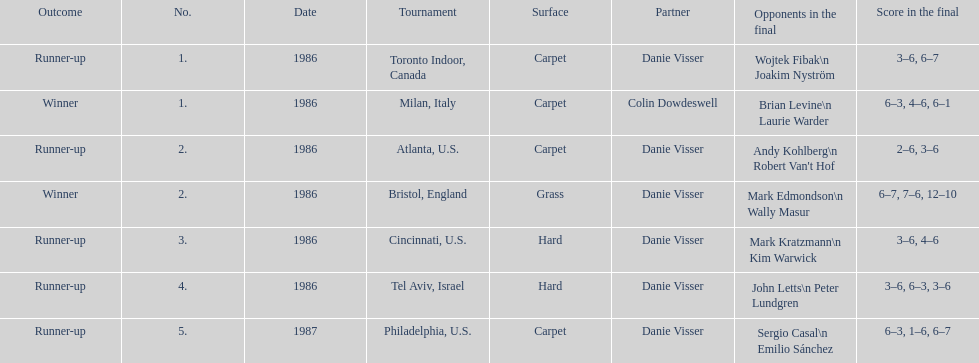Who is mentioned as the final partner? Danie Visser. 